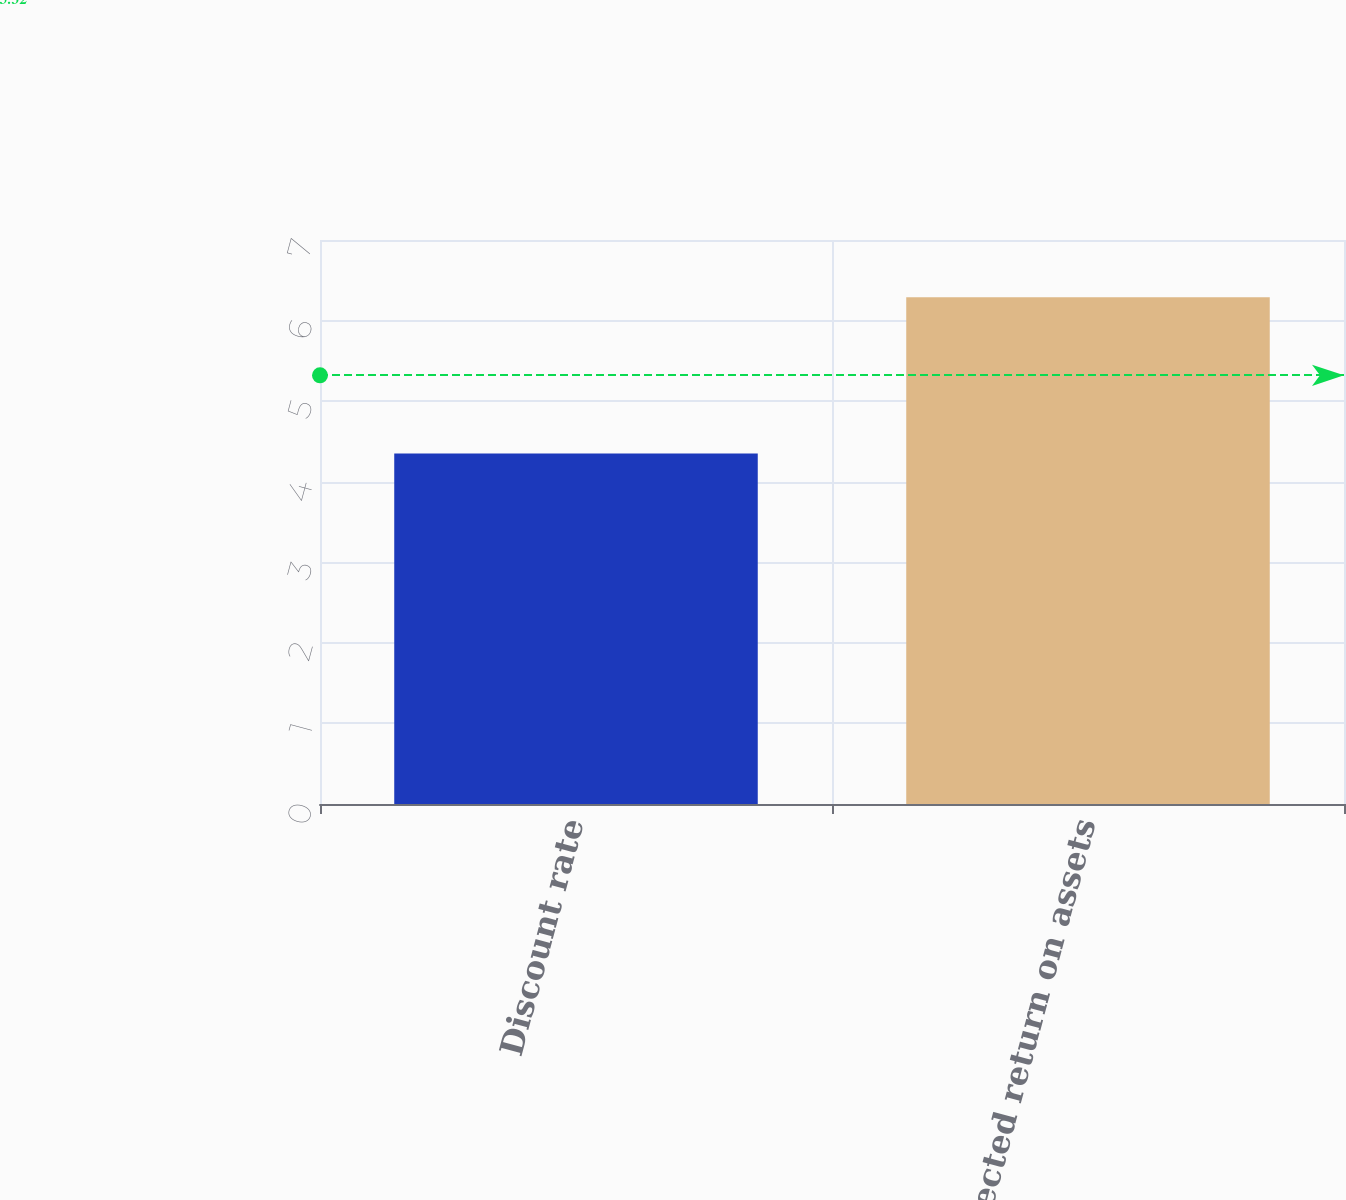Convert chart. <chart><loc_0><loc_0><loc_500><loc_500><bar_chart><fcel>Discount rate<fcel>Expected return on assets<nl><fcel>4.35<fcel>6.29<nl></chart> 